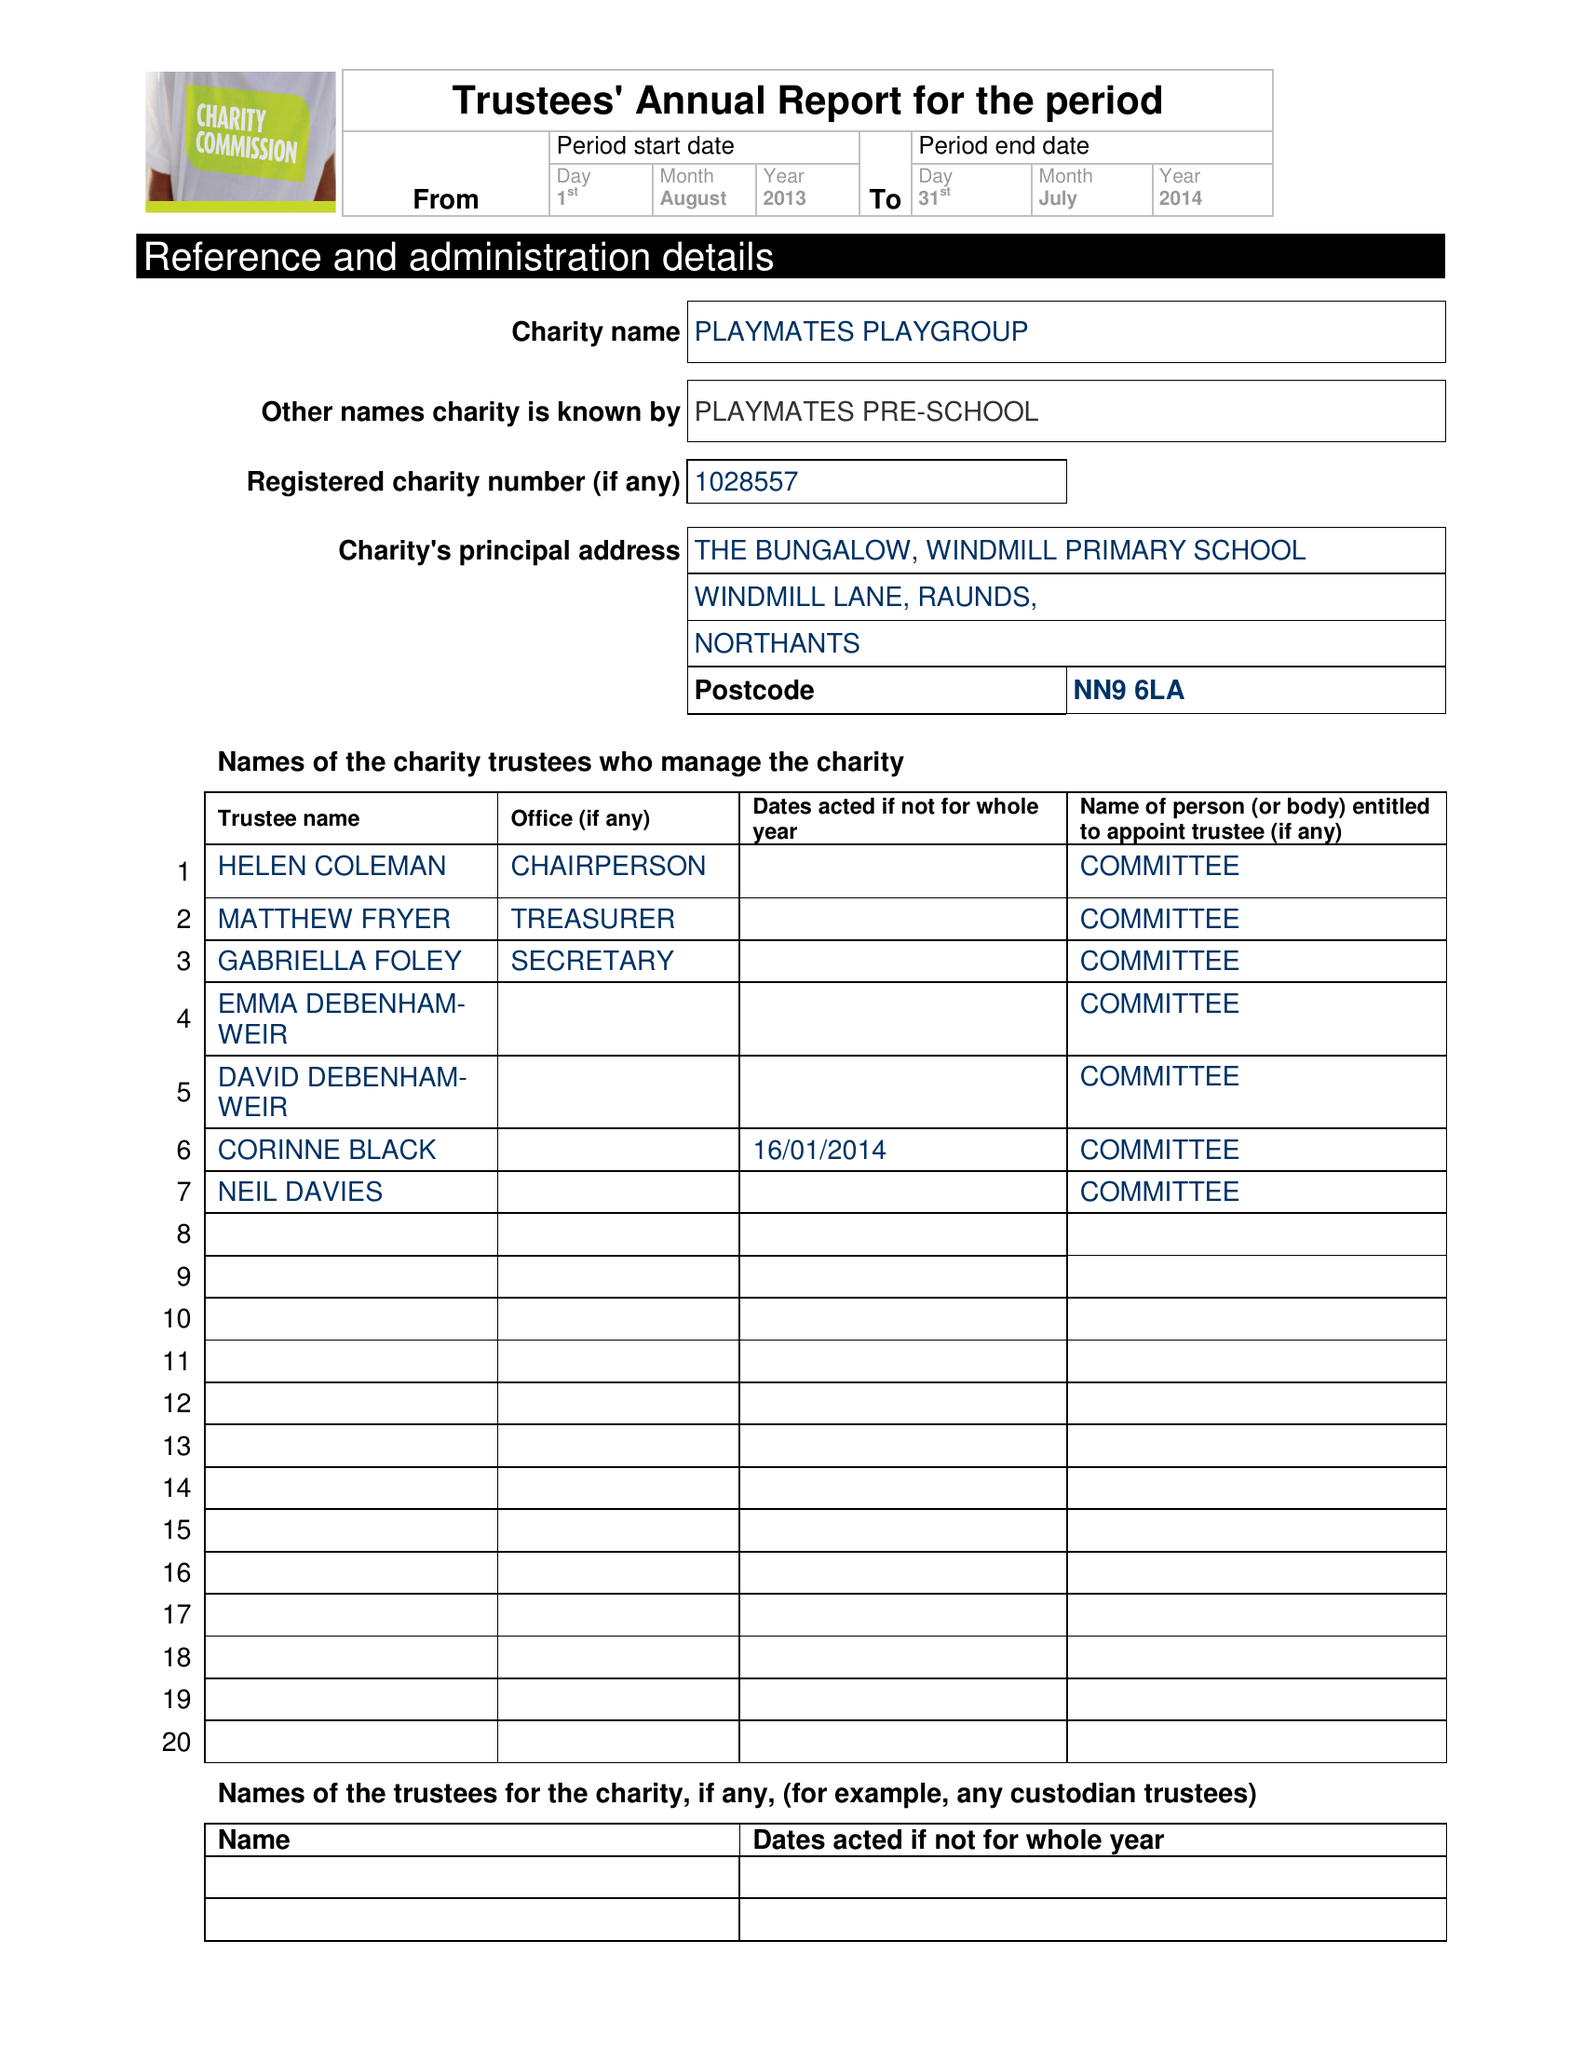What is the value for the address__postcode?
Answer the question using a single word or phrase. NN9 6LA 